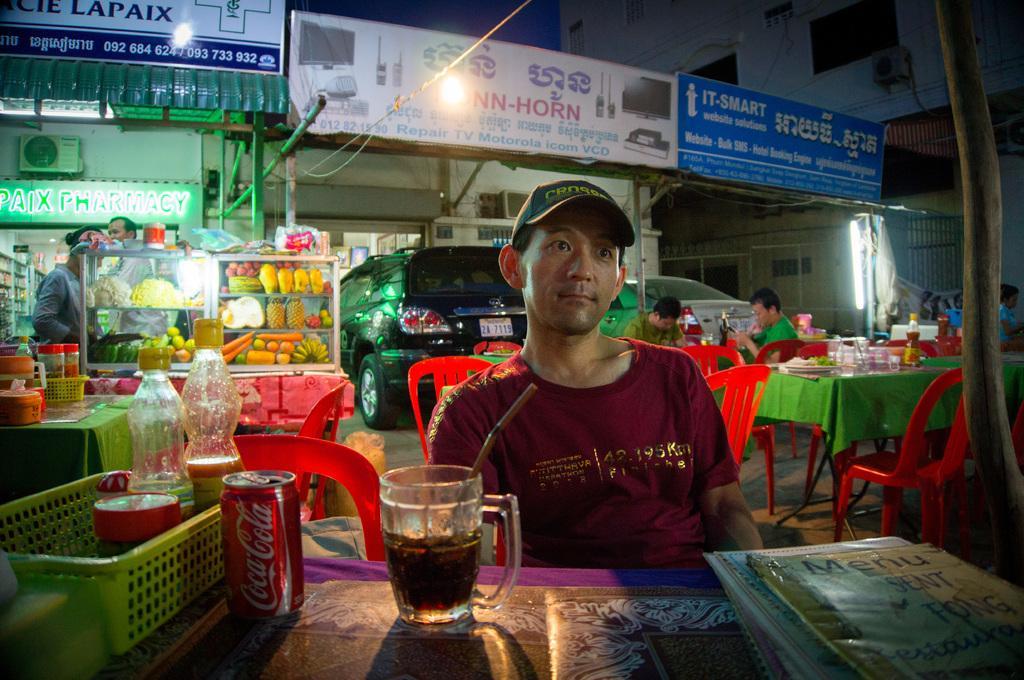In one or two sentences, can you explain what this image depicts? In this image, we can see few peoples are sat. On the right side and the middle. On the left side, few are standing. Here we can see fruits. There are few tables, chairs. We can see tin, bottles, juice, basket. There are so many tables in this image. The background ,we can see vehicles, some stalls, boards,building, sky, light, wire. 